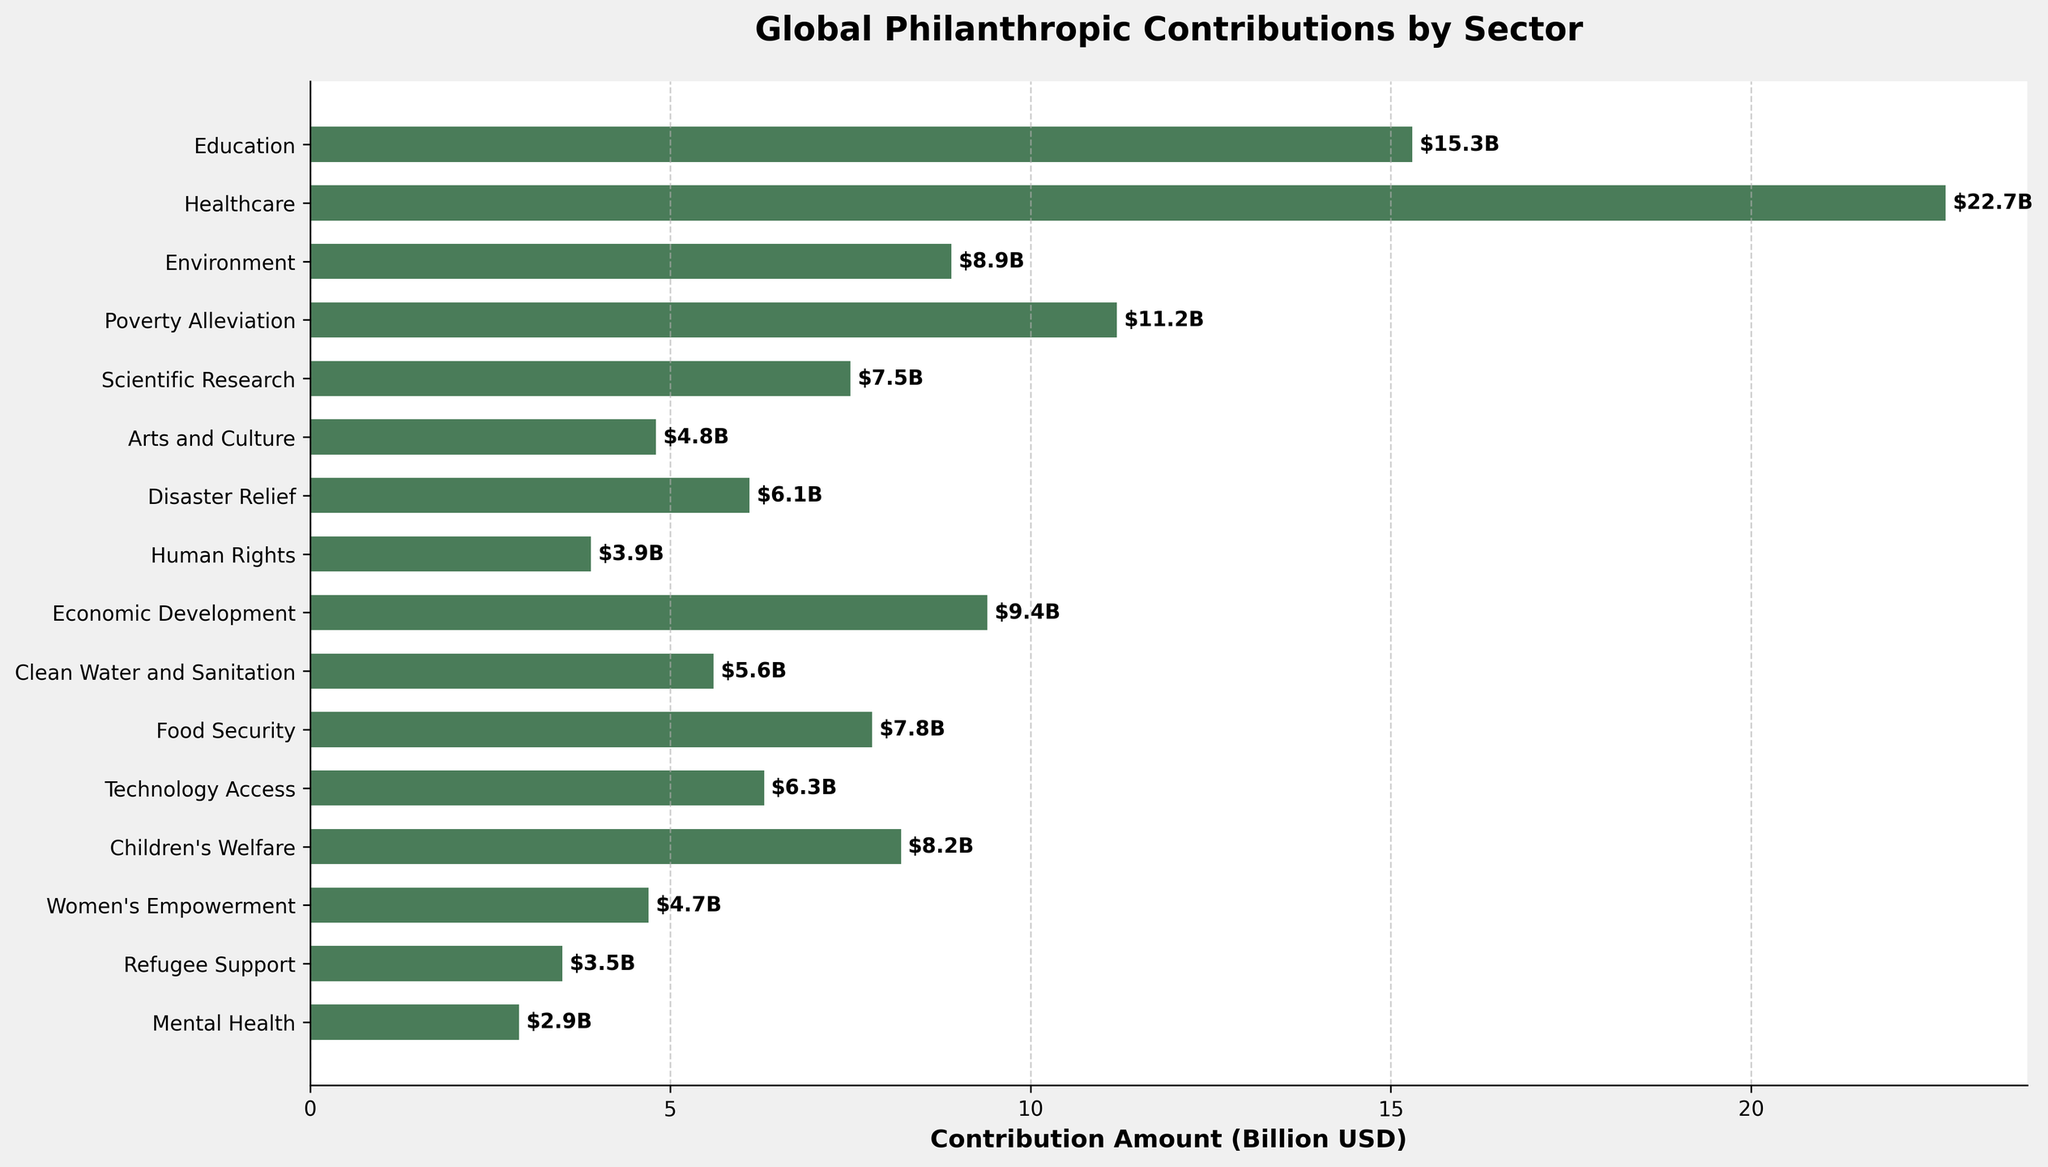Which sector has the highest contribution amount? The bar corresponding to the Healthcare sector is the longest, indicating it has the highest contribution amount.
Answer: Healthcare What is the total contribution for Education and Healthcare sectors combined? The contribution for Education is $15.3B and for Healthcare is $22.7B. Adding these amounts: 15.3 + 22.7 = 38.0
Answer: 38.0 Billion USD Which sector received more contributions, Arts and Culture or Women's Empowerment? The bar for Arts and Culture reaches $4.8B, while Women's Empowerment is at $4.7B. Comparing these values, Arts and Culture received more contributions.
Answer: Arts and Culture How much more funding did Children's Welfare receive compared to Mental Health? The contribution for Children's Welfare is $8.2B, and for Mental Health, it is $2.9B. Subtracting these values: 8.2 - 2.9 = 5.3
Answer: 5.3 Billion USD Rank the top three sectors by contribution amount. Observing the lengths of the bars, the top three sectors are: 1. Healthcare ($22.7B), 2. Education ($15.3B), 3. Poverty Alleviation ($11.2B).
Answer: Healthcare, Education, Poverty Alleviation What is the average contribution amount across all sectors? Sum all contribution amounts: 15.3 + 22.7 + 8.9 + 11.2 + 7.5 + 4.8 + 6.1 + 3.9 + 9.4 + 5.6 + 7.8 + 6.3 + 8.2 + 4.7 + 3.5 + 2.9 = 129.8. There are 16 sectors, so average: 129.8 / 16 = 8.1125
Answer: 8.1 Billion USD Which sectors have a contribution amount greater than $10 billion? The bars for Healthcare ($22.7B), Education ($15.3B), and Poverty Alleviation ($11.2B) are above the $10B mark.
Answer: Healthcare, Education, Poverty Alleviation By how much does the contribution to Disaster Relief exceed that to Mental Health? The contribution to Disaster Relief is $6.1B, and to Mental Health is $2.9B. Subtracting these values: 6.1 - 2.9 = 3.2
Answer: 3.2 Billion USD What is the median contribution amount? Listing the contributions in ascending order: 2.9, 3.5, 3.9, 4.7, 4.8, 5.6, 6.1, 6.3, 7.5, 7.8, 8.2, 8.9, 9.4, 11.2, 15.3, 22.7. There are 16 values, so the median is the average of the 8th and 9th values: (6.3 + 7.5) / 2 = 6.9
Answer: 6.9 Billion USD What is the difference in contribution between Economic Development and Environment? The contribution for Economic Development is $9.4B, and for Environment it is $8.9B. Subtracting these values: 9.4 - 8.9 = 0.5
Answer: 0.5 Billion USD 